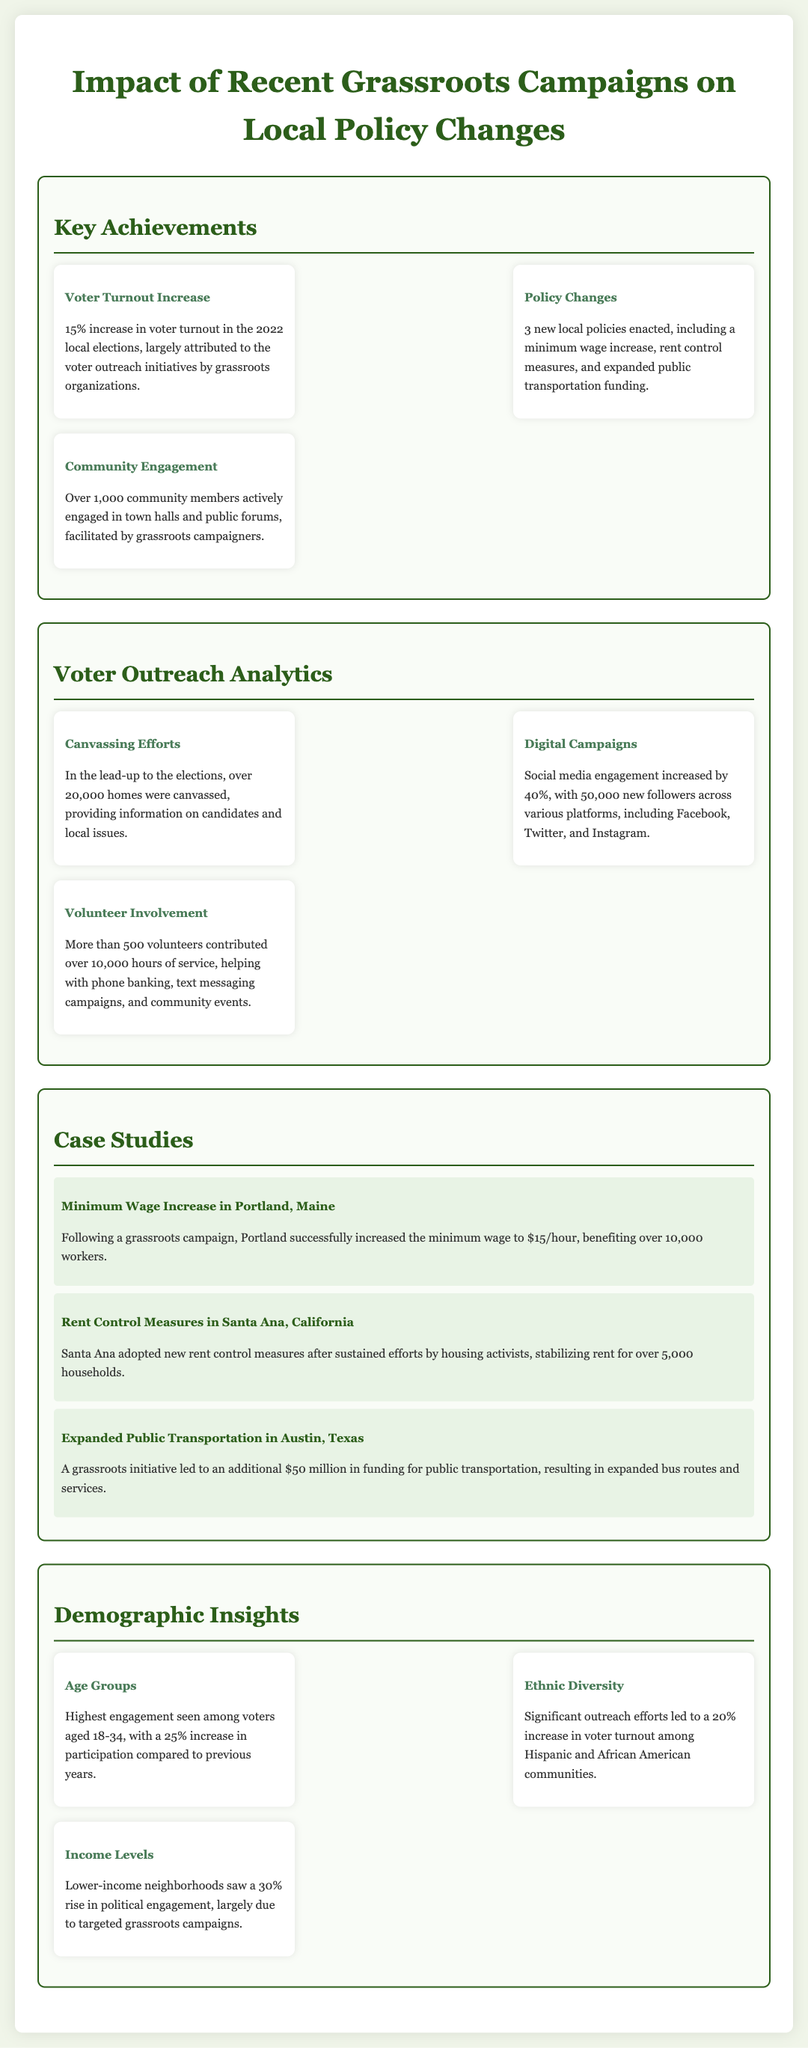what was the increase in voter turnout in the 2022 local elections? The document states there was a 15% increase in voter turnout attributed to grassroots organizations.
Answer: 15% how many new local policies were enacted? Three new local policies were enacted as mentioned in the key achievements section.
Answer: 3 what was the engagement increase among voters aged 18-34? The document notes a 25% increase in participation among this age group.
Answer: 25% how many homes were canvassed before the elections? The infographic details that over 20,000 homes were canvassed to provide information.
Answer: 20,000 which city increased the minimum wage to $15/hour? The case study mentions that Portland, Maine raised its minimum wage after a grassroots campaign.
Answer: Portland, Maine how many volunteers contributed hours to grassroots campaigns? The document indicates that more than 500 volunteers contributed over 10,000 hours of service.
Answer: 10,000 hours what was the percentage increase in social media engagement? Social media engagement increased by 40% as noted in the voter outreach analytics section.
Answer: 40% how many community members engaged in town halls and public forums? The document states over 1,000 community members actively engaged in these events.
Answer: 1,000 